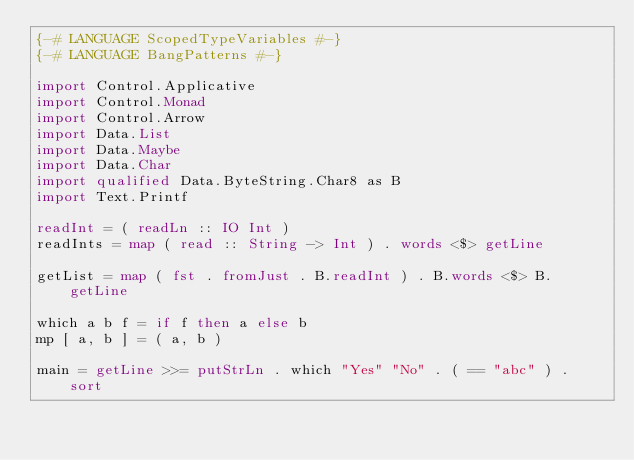<code> <loc_0><loc_0><loc_500><loc_500><_Haskell_>{-# LANGUAGE ScopedTypeVariables #-}
{-# LANGUAGE BangPatterns #-}

import Control.Applicative
import Control.Monad
import Control.Arrow
import Data.List
import Data.Maybe
import Data.Char
import qualified Data.ByteString.Char8 as B
import Text.Printf

readInt = ( readLn :: IO Int )
readInts = map ( read :: String -> Int ) . words <$> getLine

getList = map ( fst . fromJust . B.readInt ) . B.words <$> B.getLine

which a b f = if f then a else b
mp [ a, b ] = ( a, b )

main = getLine >>= putStrLn . which "Yes" "No" . ( == "abc" ) . sort</code> 